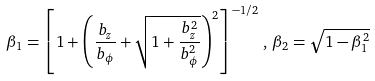<formula> <loc_0><loc_0><loc_500><loc_500>\beta _ { 1 } = \left [ 1 + \left ( \frac { b _ { z } } { b _ { \phi } } + \sqrt { 1 + \frac { b _ { z } ^ { 2 } } { b _ { \phi } ^ { 2 } } } \right ) ^ { 2 } \right ] ^ { - 1 / 2 } \, , \, \beta _ { 2 } = \sqrt { 1 - \beta _ { 1 } ^ { 2 } }</formula> 